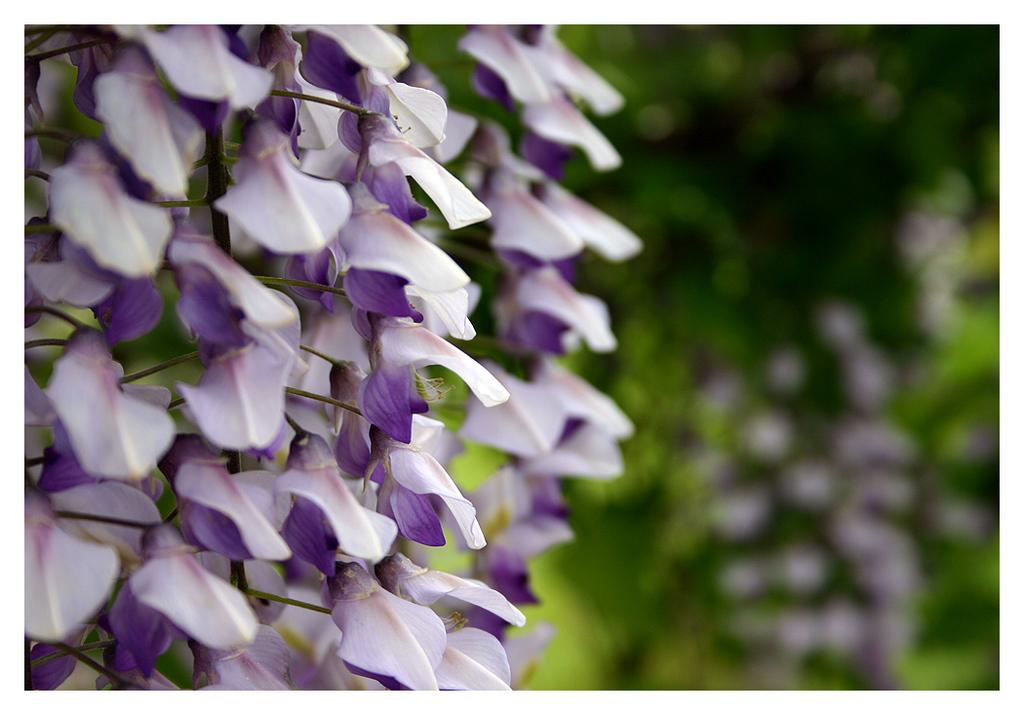What type of living organisms can be seen in the image? There are flowers in the image. How many sheep are in the flock that is crossing the bridge in the image? There is no flock of sheep or bridge present in the image; it only features flowers. 